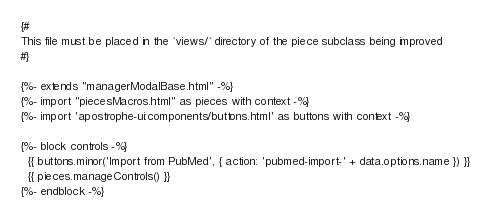Convert code to text. <code><loc_0><loc_0><loc_500><loc_500><_HTML_>{#
This file must be placed in the `views/` directory of the piece subclass being improved
#}

{%- extends "managerModalBase.html" -%}
{%- import "piecesMacros.html" as pieces with context -%}
{%- import 'apostrophe-ui:components/buttons.html' as buttons with context -%}

{%- block controls -%}
  {{ buttons.minor('Import from PubMed', { action: 'pubmed-import-' + data.options.name }) }}
  {{ pieces.manageControls() }}
{%- endblock -%}</code> 